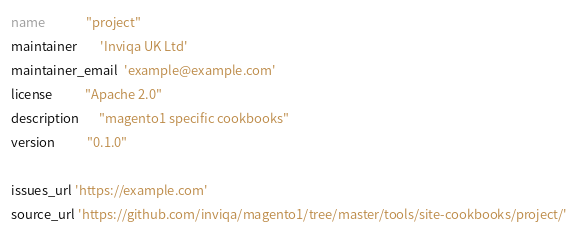<code> <loc_0><loc_0><loc_500><loc_500><_Ruby_>name              "project"
maintainer        'Inviqa UK Ltd'
maintainer_email  'example@example.com'
license           "Apache 2.0"
description       "magento1 specific cookbooks"
version           "0.1.0"

issues_url 'https://example.com'
source_url 'https://github.com/inviqa/magento1/tree/master/tools/site-cookbooks/project/'
</code> 